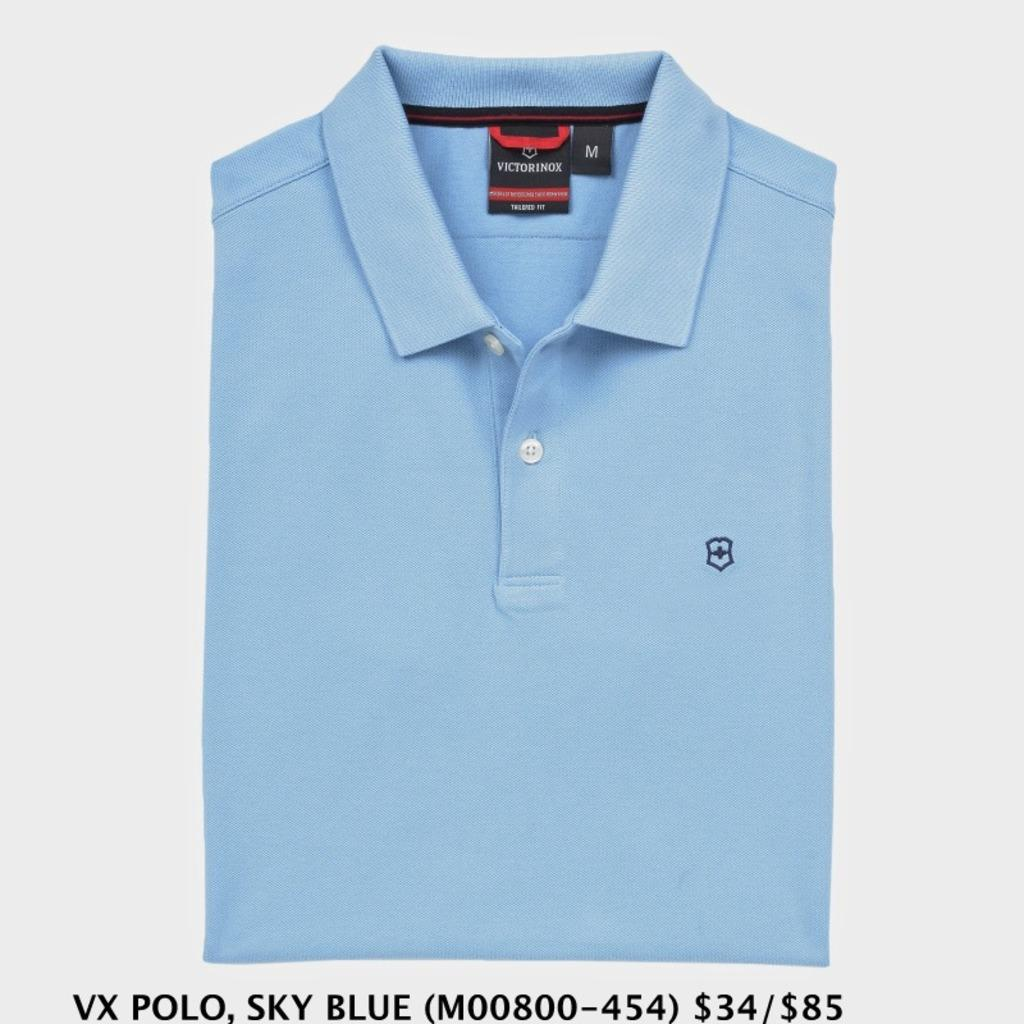<image>
Render a clear and concise summary of the photo. A blue Victorinox polo sits against a white background 